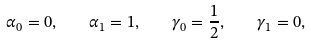<formula> <loc_0><loc_0><loc_500><loc_500>\alpha _ { 0 } = 0 , \quad \alpha _ { 1 } = 1 , \quad \gamma _ { 0 } = \frac { 1 } { 2 } , \quad \gamma _ { 1 } = 0 ,</formula> 